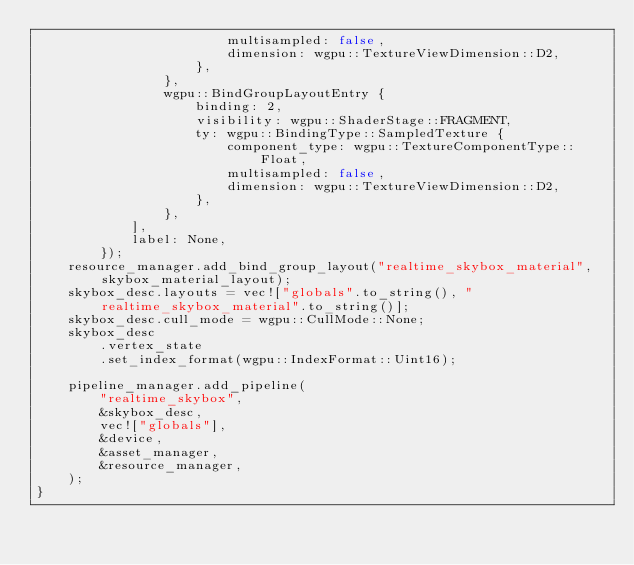<code> <loc_0><loc_0><loc_500><loc_500><_Rust_>                        multisampled: false,
                        dimension: wgpu::TextureViewDimension::D2,
                    },
                },
                wgpu::BindGroupLayoutEntry {
                    binding: 2,
                    visibility: wgpu::ShaderStage::FRAGMENT,
                    ty: wgpu::BindingType::SampledTexture {
                        component_type: wgpu::TextureComponentType::Float,
                        multisampled: false,
                        dimension: wgpu::TextureViewDimension::D2,
                    },
                },
            ],
            label: None,
        });
    resource_manager.add_bind_group_layout("realtime_skybox_material", skybox_material_layout);
    skybox_desc.layouts = vec!["globals".to_string(), "realtime_skybox_material".to_string()];
    skybox_desc.cull_mode = wgpu::CullMode::None;
    skybox_desc
        .vertex_state
        .set_index_format(wgpu::IndexFormat::Uint16);

    pipeline_manager.add_pipeline(
        "realtime_skybox",
        &skybox_desc,
        vec!["globals"],
        &device,
        &asset_manager,
        &resource_manager,
    );
}
</code> 